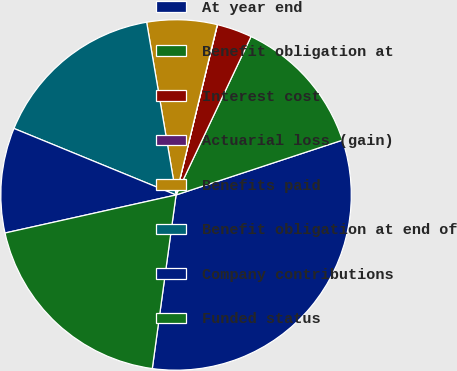Convert chart. <chart><loc_0><loc_0><loc_500><loc_500><pie_chart><fcel>At year end<fcel>Benefit obligation at<fcel>Interest cost<fcel>Actuarial loss (gain)<fcel>Benefits paid<fcel>Benefit obligation at end of<fcel>Company contributions<fcel>Funded status<nl><fcel>32.23%<fcel>12.9%<fcel>3.24%<fcel>0.02%<fcel>6.46%<fcel>16.12%<fcel>9.68%<fcel>19.35%<nl></chart> 